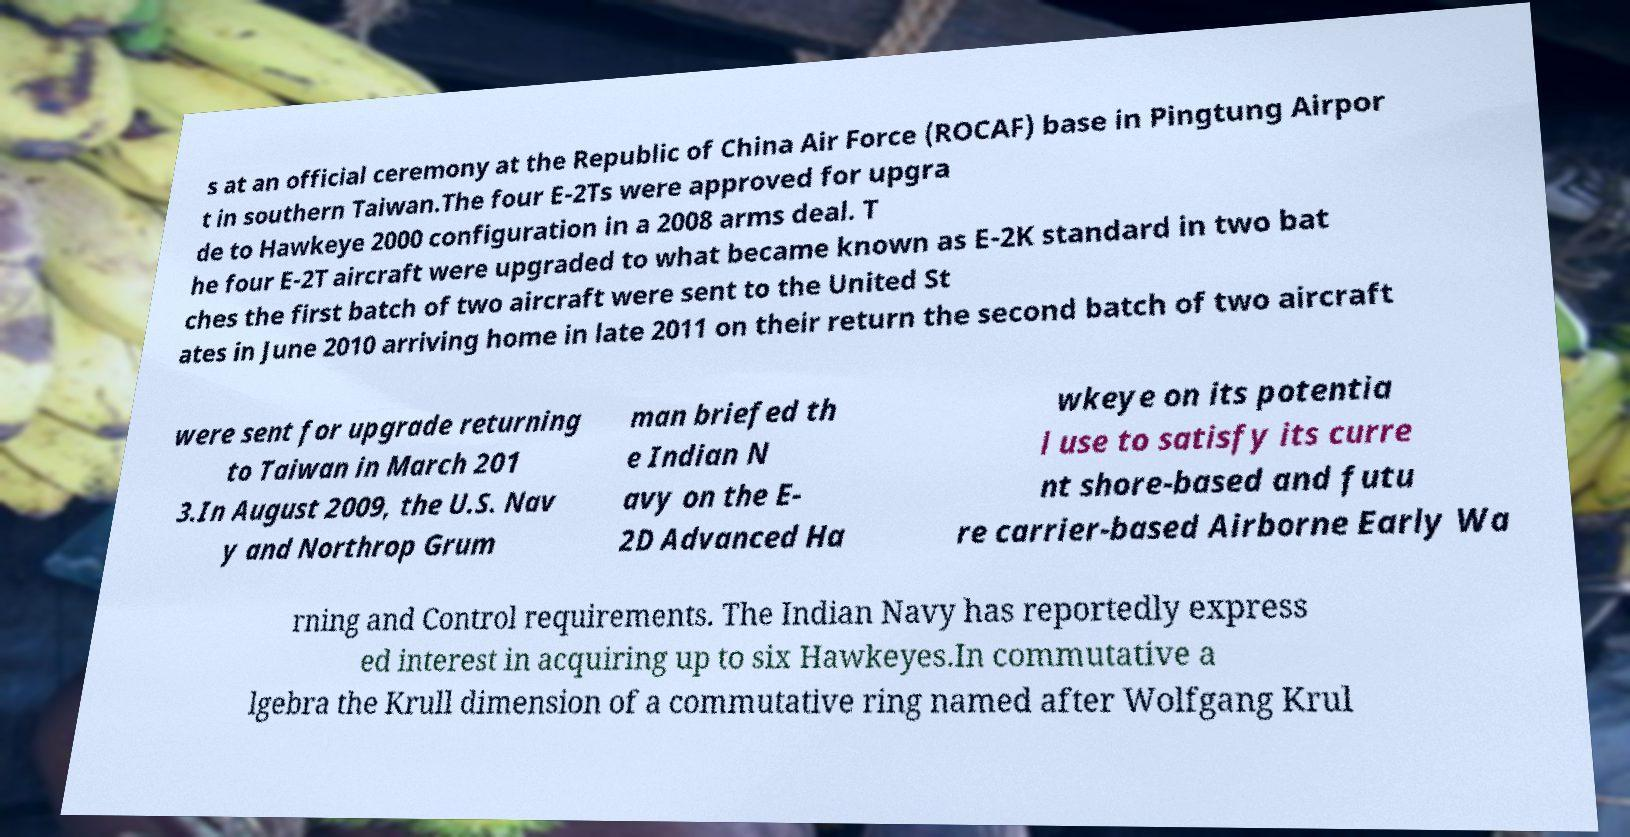Could you extract and type out the text from this image? s at an official ceremony at the Republic of China Air Force (ROCAF) base in Pingtung Airpor t in southern Taiwan.The four E-2Ts were approved for upgra de to Hawkeye 2000 configuration in a 2008 arms deal. T he four E-2T aircraft were upgraded to what became known as E-2K standard in two bat ches the first batch of two aircraft were sent to the United St ates in June 2010 arriving home in late 2011 on their return the second batch of two aircraft were sent for upgrade returning to Taiwan in March 201 3.In August 2009, the U.S. Nav y and Northrop Grum man briefed th e Indian N avy on the E- 2D Advanced Ha wkeye on its potentia l use to satisfy its curre nt shore-based and futu re carrier-based Airborne Early Wa rning and Control requirements. The Indian Navy has reportedly express ed interest in acquiring up to six Hawkeyes.In commutative a lgebra the Krull dimension of a commutative ring named after Wolfgang Krul 